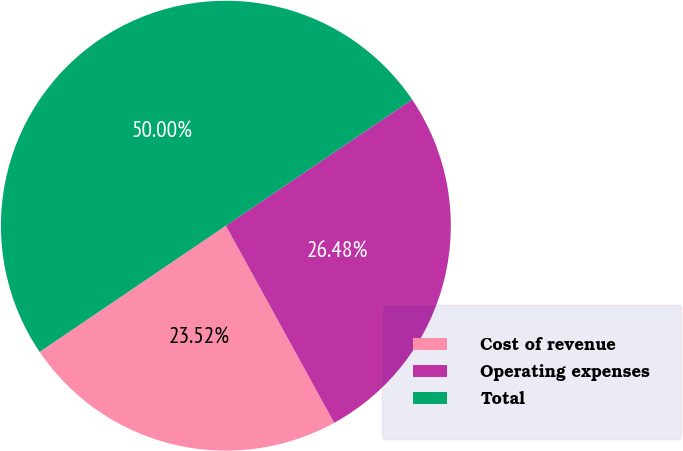Convert chart to OTSL. <chart><loc_0><loc_0><loc_500><loc_500><pie_chart><fcel>Cost of revenue<fcel>Operating expenses<fcel>Total<nl><fcel>23.52%<fcel>26.48%<fcel>50.0%<nl></chart> 